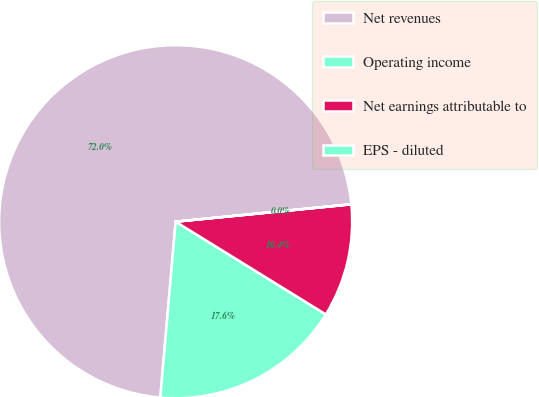Convert chart. <chart><loc_0><loc_0><loc_500><loc_500><pie_chart><fcel>Net revenues<fcel>Operating income<fcel>Net earnings attributable to<fcel>EPS - diluted<nl><fcel>72.04%<fcel>17.58%<fcel>10.37%<fcel>0.01%<nl></chart> 